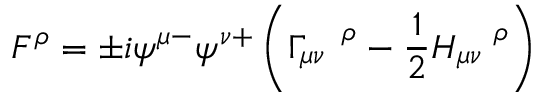<formula> <loc_0><loc_0><loc_500><loc_500>F ^ { \rho } = \pm i \psi ^ { \mu - } \psi ^ { \nu + } \left ( \Gamma _ { \mu \nu } ^ { \quad \rho } - \frac { 1 } { 2 } H _ { \mu \nu } ^ { \quad \rho } \right )</formula> 